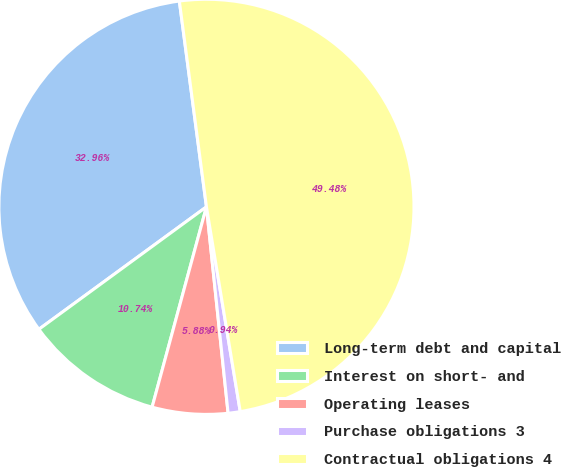Convert chart to OTSL. <chart><loc_0><loc_0><loc_500><loc_500><pie_chart><fcel>Long-term debt and capital<fcel>Interest on short- and<fcel>Operating leases<fcel>Purchase obligations 3<fcel>Contractual obligations 4<nl><fcel>32.96%<fcel>10.74%<fcel>5.88%<fcel>0.94%<fcel>49.48%<nl></chart> 